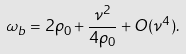Convert formula to latex. <formula><loc_0><loc_0><loc_500><loc_500>\omega _ { b } = 2 \rho _ { 0 } + \frac { \nu ^ { 2 } } { 4 \rho _ { 0 } } + O ( \nu ^ { 4 } ) .</formula> 